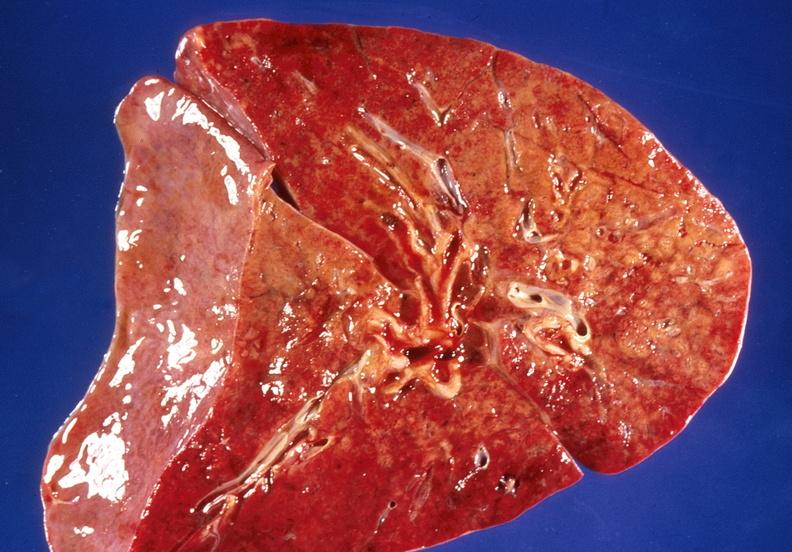s respiratory present?
Answer the question using a single word or phrase. Yes 